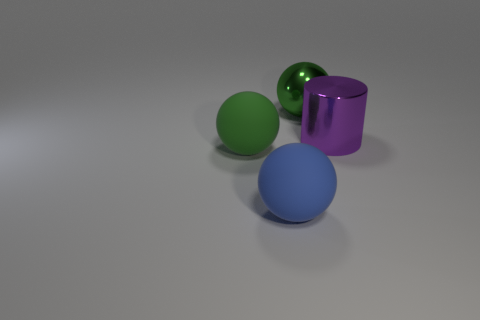There is a matte thing that is the same color as the metallic ball; what is its shape?
Your answer should be compact. Sphere. There is another ball that is the same color as the metal ball; what is its size?
Keep it short and to the point. Large. There is a purple cylinder; is its size the same as the green sphere behind the green matte object?
Offer a very short reply. Yes. What is the big green sphere behind the green ball that is in front of the large green sphere behind the large purple cylinder made of?
Offer a very short reply. Metal. What number of things are big metal cylinders or tiny blue metallic blocks?
Your response must be concise. 1. Does the big metallic thing that is behind the purple metallic cylinder have the same color as the large thing that is right of the big green metallic object?
Your response must be concise. No. What shape is the blue object that is the same size as the shiny sphere?
Your answer should be compact. Sphere. What number of things are metallic objects that are behind the metal cylinder or large balls that are behind the purple metallic cylinder?
Your answer should be very brief. 1. Is the number of cubes less than the number of big shiny balls?
Offer a terse response. Yes. There is a blue ball that is the same size as the purple thing; what is it made of?
Provide a short and direct response. Rubber. 